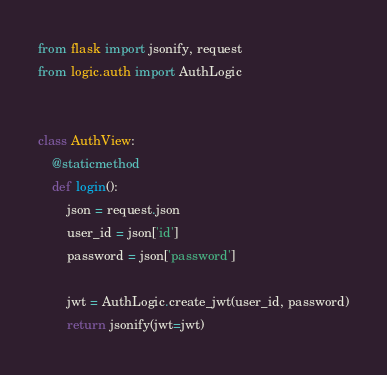<code> <loc_0><loc_0><loc_500><loc_500><_Python_>from flask import jsonify, request
from logic.auth import AuthLogic


class AuthView:
    @staticmethod
    def login():
        json = request.json
        user_id = json['id']
        password = json['password']

        jwt = AuthLogic.create_jwt(user_id, password)
        return jsonify(jwt=jwt)
</code> 